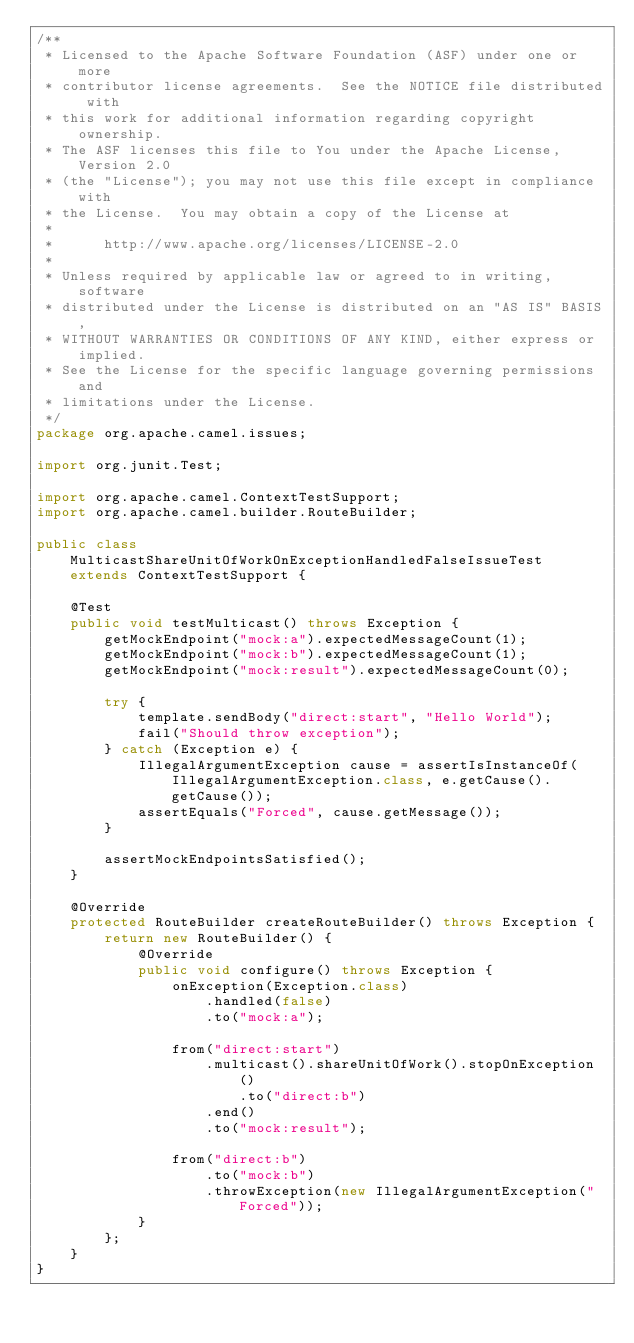<code> <loc_0><loc_0><loc_500><loc_500><_Java_>/**
 * Licensed to the Apache Software Foundation (ASF) under one or more
 * contributor license agreements.  See the NOTICE file distributed with
 * this work for additional information regarding copyright ownership.
 * The ASF licenses this file to You under the Apache License, Version 2.0
 * (the "License"); you may not use this file except in compliance with
 * the License.  You may obtain a copy of the License at
 *
 *      http://www.apache.org/licenses/LICENSE-2.0
 *
 * Unless required by applicable law or agreed to in writing, software
 * distributed under the License is distributed on an "AS IS" BASIS,
 * WITHOUT WARRANTIES OR CONDITIONS OF ANY KIND, either express or implied.
 * See the License for the specific language governing permissions and
 * limitations under the License.
 */
package org.apache.camel.issues;

import org.junit.Test;

import org.apache.camel.ContextTestSupport;
import org.apache.camel.builder.RouteBuilder;

public class MulticastShareUnitOfWorkOnExceptionHandledFalseIssueTest extends ContextTestSupport {

    @Test
    public void testMulticast() throws Exception {
        getMockEndpoint("mock:a").expectedMessageCount(1);
        getMockEndpoint("mock:b").expectedMessageCount(1);
        getMockEndpoint("mock:result").expectedMessageCount(0);

        try {
            template.sendBody("direct:start", "Hello World");
            fail("Should throw exception");
        } catch (Exception e) {
            IllegalArgumentException cause = assertIsInstanceOf(IllegalArgumentException.class, e.getCause().getCause());
            assertEquals("Forced", cause.getMessage());
        }

        assertMockEndpointsSatisfied();
    }

    @Override
    protected RouteBuilder createRouteBuilder() throws Exception {
        return new RouteBuilder() {
            @Override
            public void configure() throws Exception {
                onException(Exception.class)
                    .handled(false)
                    .to("mock:a");

                from("direct:start")
                    .multicast().shareUnitOfWork().stopOnException()
                        .to("direct:b")
                    .end()
                    .to("mock:result");

                from("direct:b")
                    .to("mock:b")
                    .throwException(new IllegalArgumentException("Forced"));
            }
        };
    }
}
</code> 